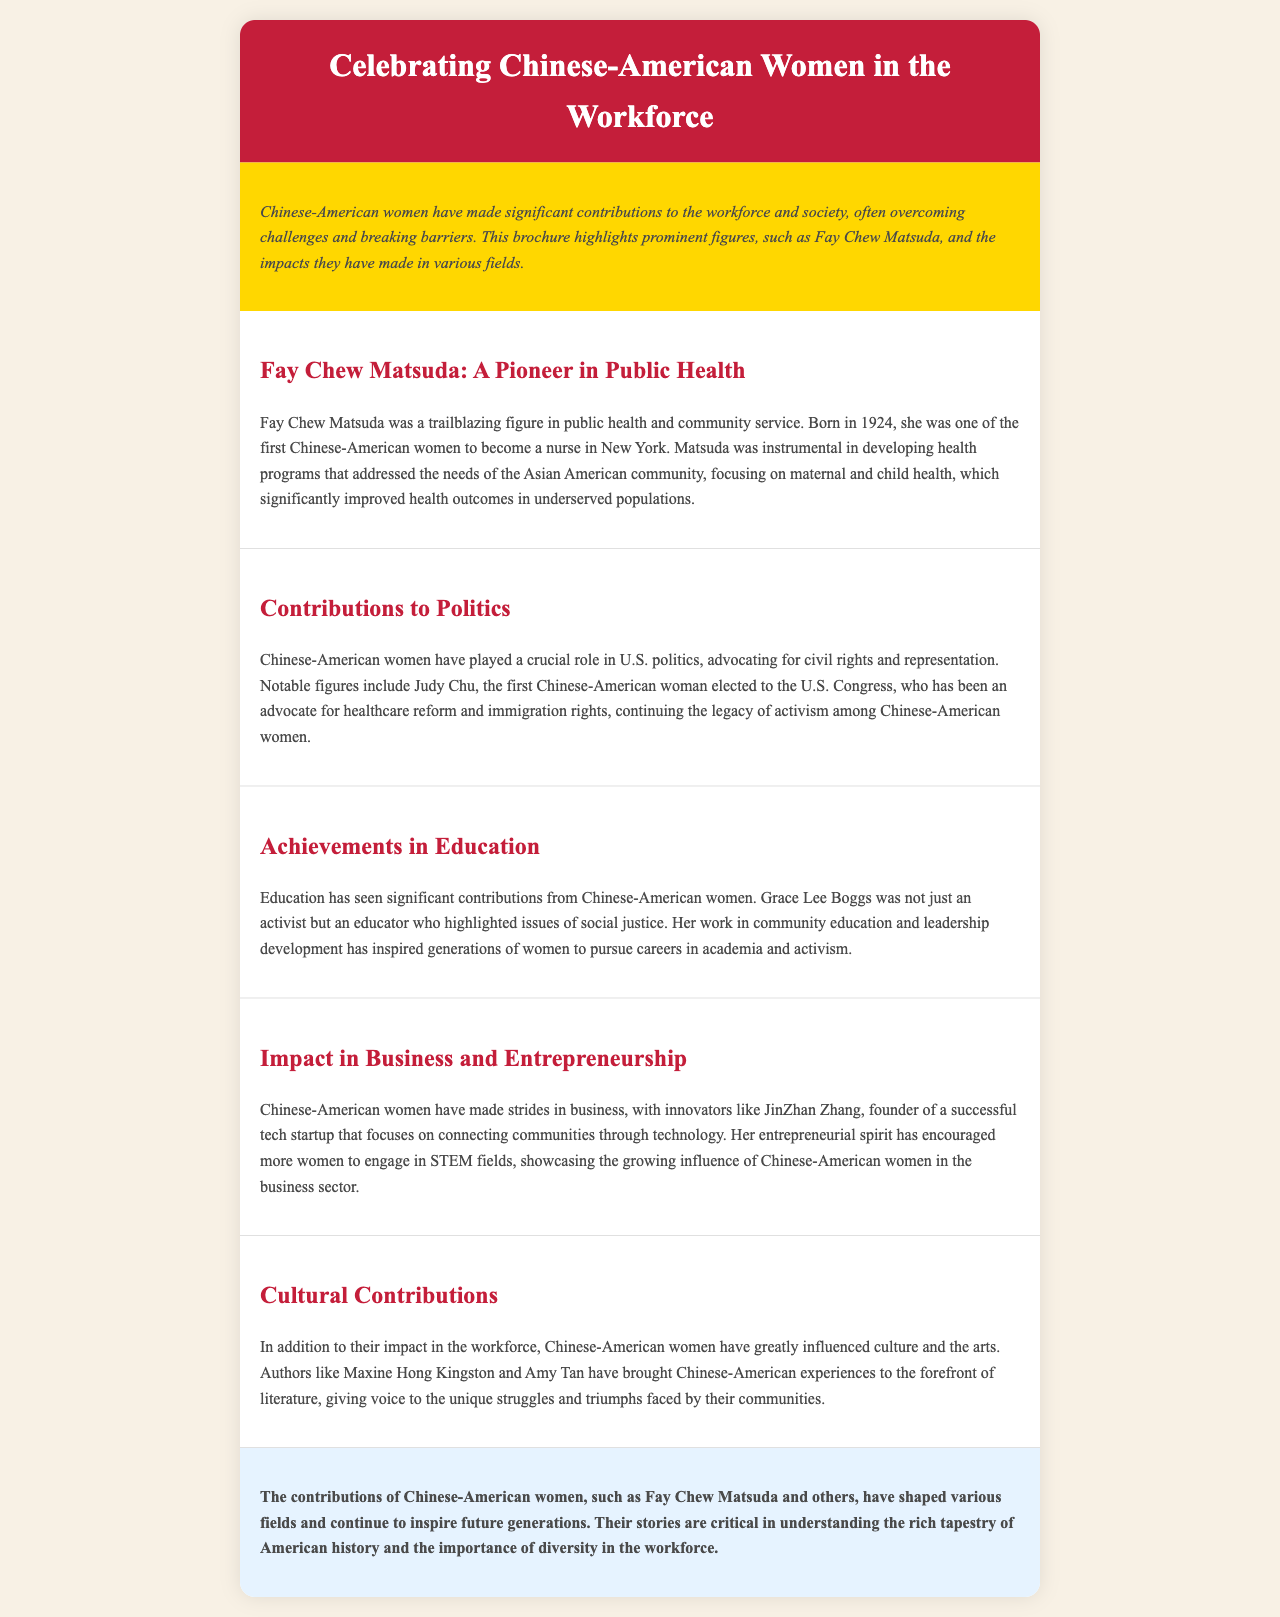What is the title of the document? The title is prominently displayed at the top of the brochure, summarizing its focus on a specific group of women.
Answer: Celebrating Chinese-American Women in the Workforce Who was a pioneer in public health mentioned in the document? The document explicitly names a key figure in the section dedicated to public health achievements, highlighting her contributions.
Answer: Fay Chew Matsuda In what year was Fay Chew Matsuda born? The year of birth of Fay Chew Matsuda is provided in her section, indicating her early life and contributions.
Answer: 1924 What field did Judy Chu contribute to in politics? Judy Chu's focus is outlined under the contributions to politics section, showcasing her advocacy efforts.
Answer: Healthcare reform Which author is mentioned for cultural contributions? The document includes notable authors who have influenced culture, specifically highlighting their works.
Answer: Maxine Hong Kingston What innovation did JinZhan Zhang contribute to? The document specifies her entrepreneurial achievement in the section about business and entrepreneurship.
Answer: Tech startup How did Grace Lee Boggs contribute to education? The document describes her role in community education and leadership development in a specific section.
Answer: Activist and educator What type of health programs did Fay Chew Matsuda focus on? The specific area of health programs that Matsuda developed is detailed in her section, reflecting her community focus.
Answer: Maternal and child health What impact have Chinese-American women had on the business sector? The document discusses the influence and achievements of women in business, outlining their growing roles.
Answer: Strides in business 